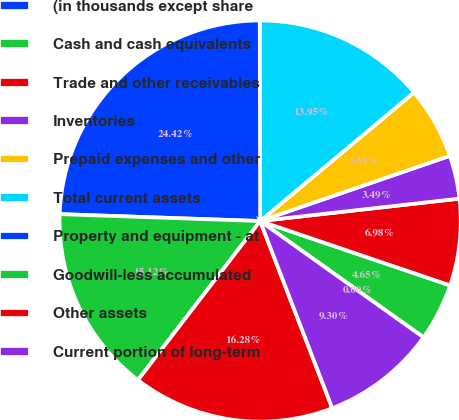Convert chart to OTSL. <chart><loc_0><loc_0><loc_500><loc_500><pie_chart><fcel>(in thousands except share<fcel>Cash and cash equivalents<fcel>Trade and other receivables<fcel>Inventories<fcel>Prepaid expenses and other<fcel>Total current assets<fcel>Property and equipment - at<fcel>Goodwill-less accumulated<fcel>Other assets<fcel>Current portion of long-term<nl><fcel>0.0%<fcel>4.65%<fcel>6.98%<fcel>3.49%<fcel>5.81%<fcel>13.95%<fcel>24.42%<fcel>15.12%<fcel>16.28%<fcel>9.3%<nl></chart> 